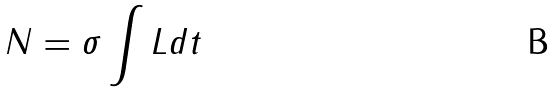<formula> <loc_0><loc_0><loc_500><loc_500>N = \sigma \int L d t</formula> 